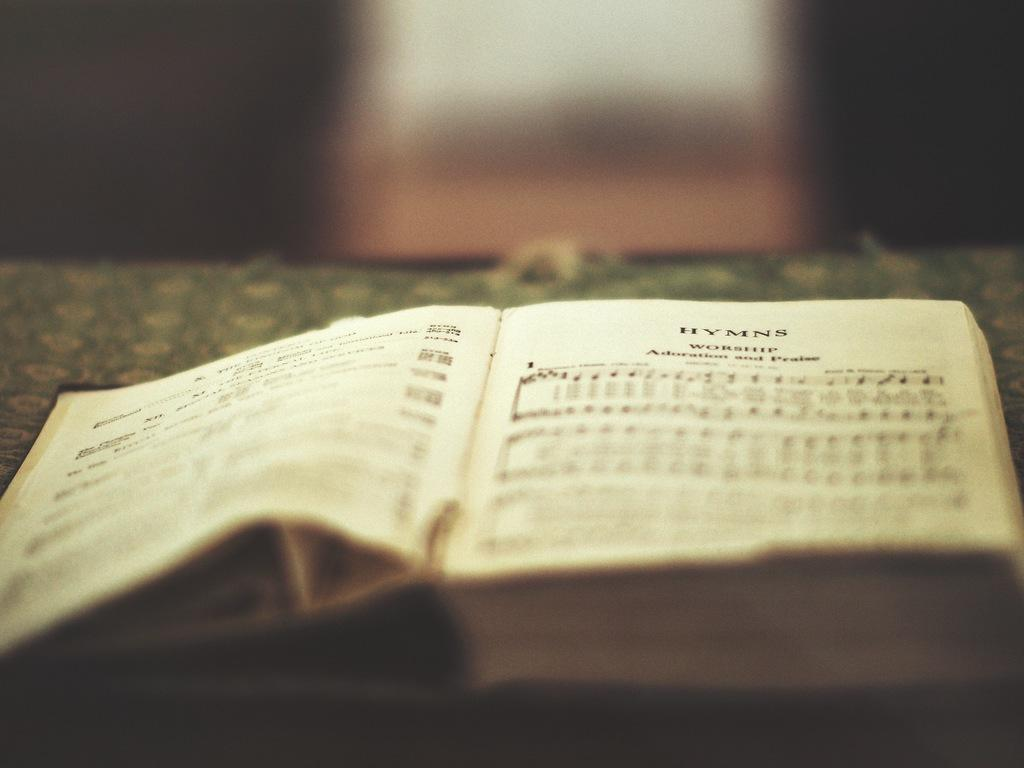What is the main object in the image? There is a book in the image. Where is the book placed? The book is on an object. What can be found on the pages of the book? There are words on the papers of the book. Can you describe the background of the image? The background of the image is blurred. What type of grass can be seen growing on the legs of the book in the image? There are no legs or grass present in the image; it features a book with blurred background. 